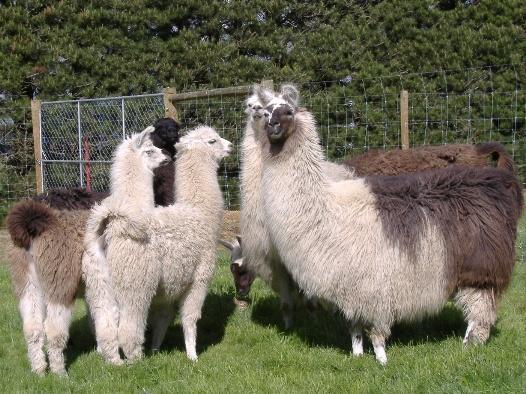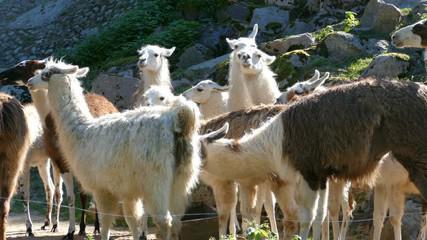The first image is the image on the left, the second image is the image on the right. Assess this claim about the two images: "There are at least two alpacas one fully white and the other light brown facing and looking straight forward .". Correct or not? Answer yes or no. No. The first image is the image on the left, the second image is the image on the right. Analyze the images presented: Is the assertion "The foreground of the right image shows only camera-gazing llamas with solid colored fur." valid? Answer yes or no. No. 